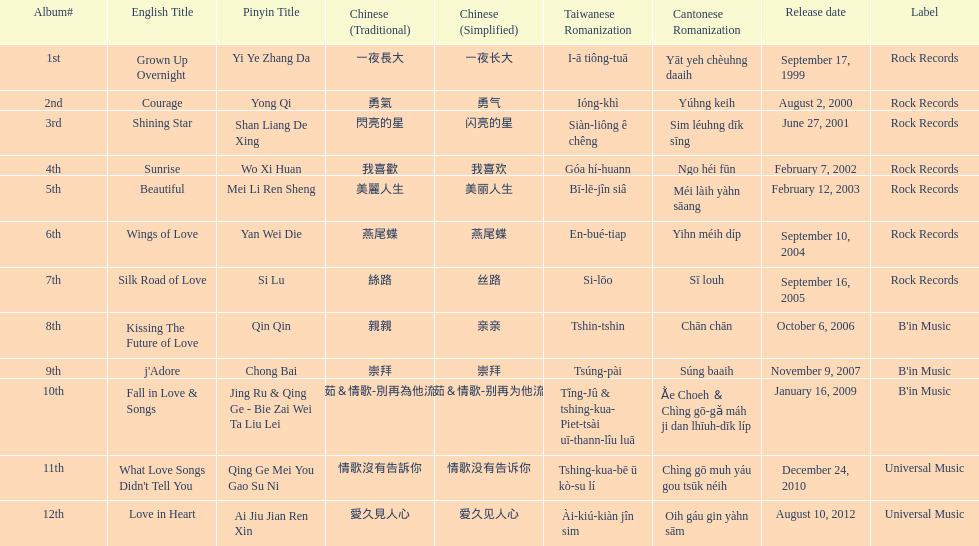What songs were on b'in music or universal music? Kissing The Future of Love, j'Adore, Fall in Love & Songs, What Love Songs Didn't Tell You, Love in Heart. 